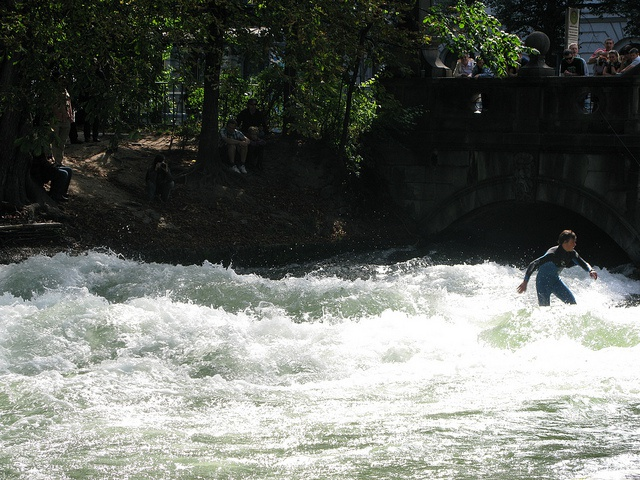Describe the objects in this image and their specific colors. I can see people in black, darkblue, gray, and blue tones, surfboard in black, white, beige, and gray tones, people in black and purple tones, people in black and gray tones, and people in black, darkgreen, and gray tones in this image. 